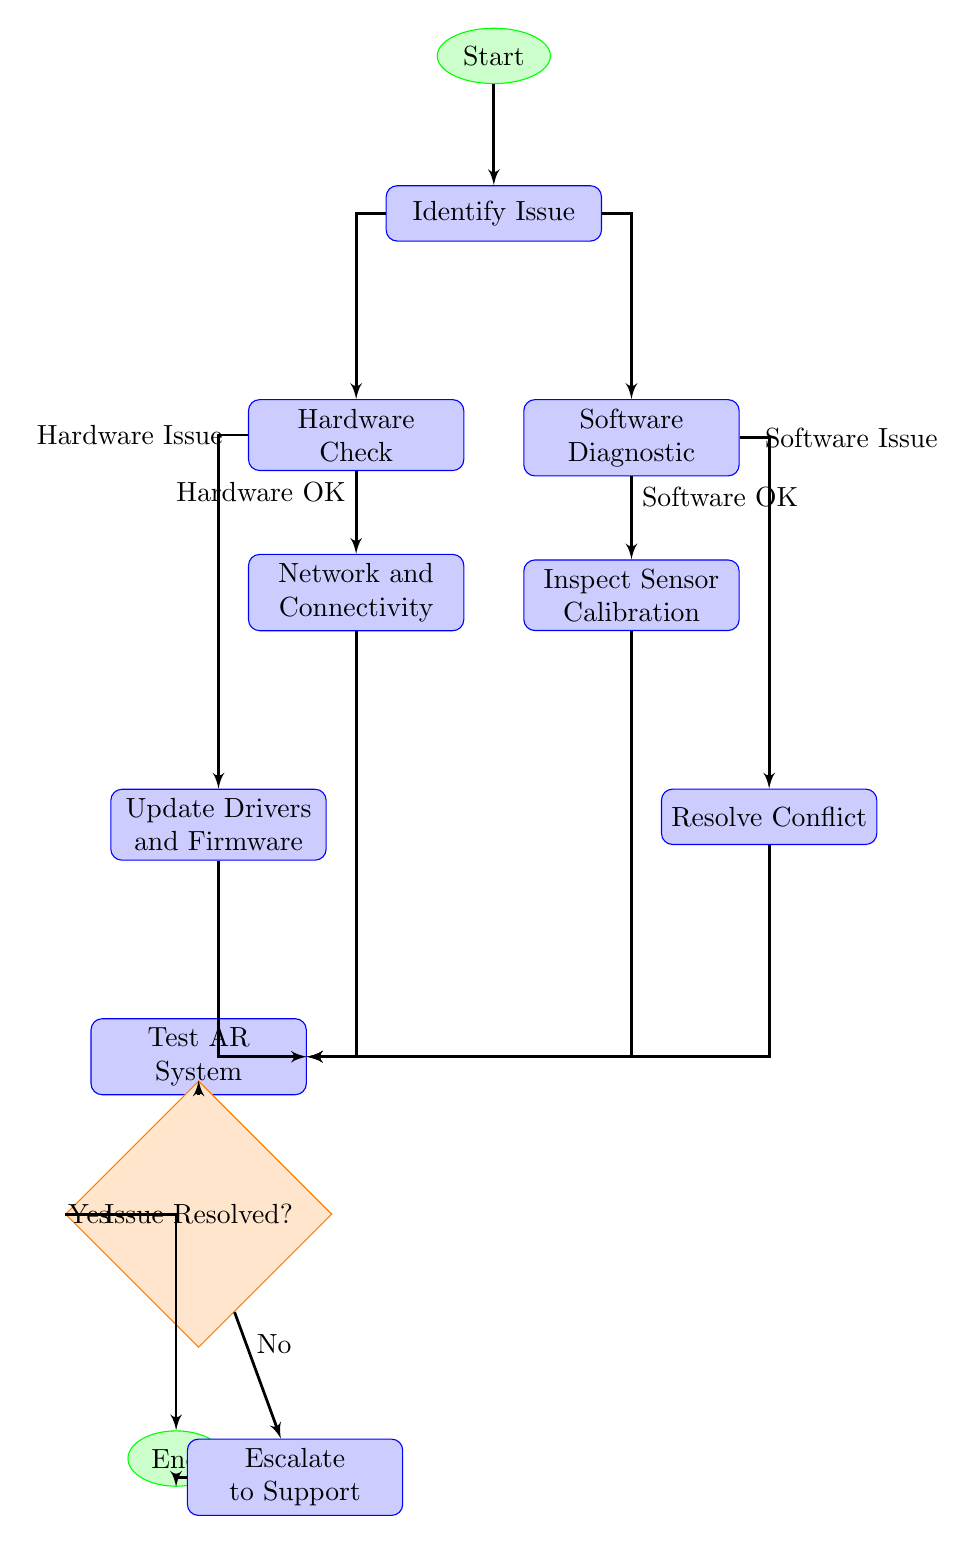What is the starting point of the workflow? The workflow begins with the "Start" node, which initiates the troubleshooting process for AR system issues.
Answer: Start How many blocks are present in the diagram? There are seven blocks in the diagram indicating different troubleshooting steps.
Answer: 7 What happens after identifying the issue? Once the issue is identified, the process branches into two potential paths: the Hardware Check and the Software Diagnostic.
Answer: Hardware Check and Software Diagnostic If the hardware check reveals a hardware issue, which step follows? If a hardware issue is identified, the next step is to "Update Drivers and Firmware." This indicates that the user should attempt to resolve the identified hardware issues before proceeding further.
Answer: Update Drivers and Firmware What determines if the issue is resolved? After testing the AR system, the decision point "Issue Resolved?" evaluates whether the troubleshooting efforts were successful or not.
Answer: Issue Resolved? What is the outcome if the issue is not resolved? If the issue is not resolved, the next step is to "Escalate to Support," indicating that further assistance is needed for resolution.
Answer: Escalate to Support Which nodes are connected to the "Software Issue"? The node "Software Issue" connects to the "Resolve Conflict" block, indicating a subsequent step to address software conflicts after diagnostic findings.
Answer: Resolve Conflict How many edges lead out from the "Test AR System"? There are two edges leading out from the "Test AR System," one leading to "Issue Resolved?" and another that connects to both the "Yes" and "No" outcomes of the decision node.
Answer: 2 What step should be performed after "Network and Connectivity"? The "Test AR System" step follows after verifying the network and connectivity, meaning that the system is tested to ensure proper functionality.
Answer: Test AR System 